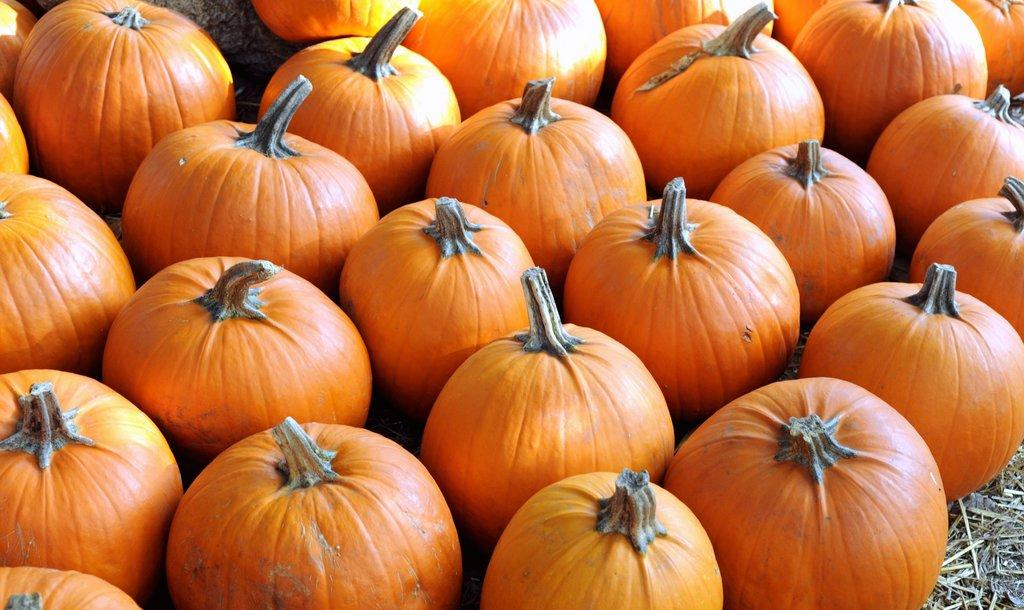What type of vegetable is featured in the image? There are pumpkins in the image. How are the pumpkins arranged? The pumpkins are arranged in a line. What type of pot can be seen next to the pumpkins in the image? There is no pot present in the image; it only features pumpkins arranged in a line. 